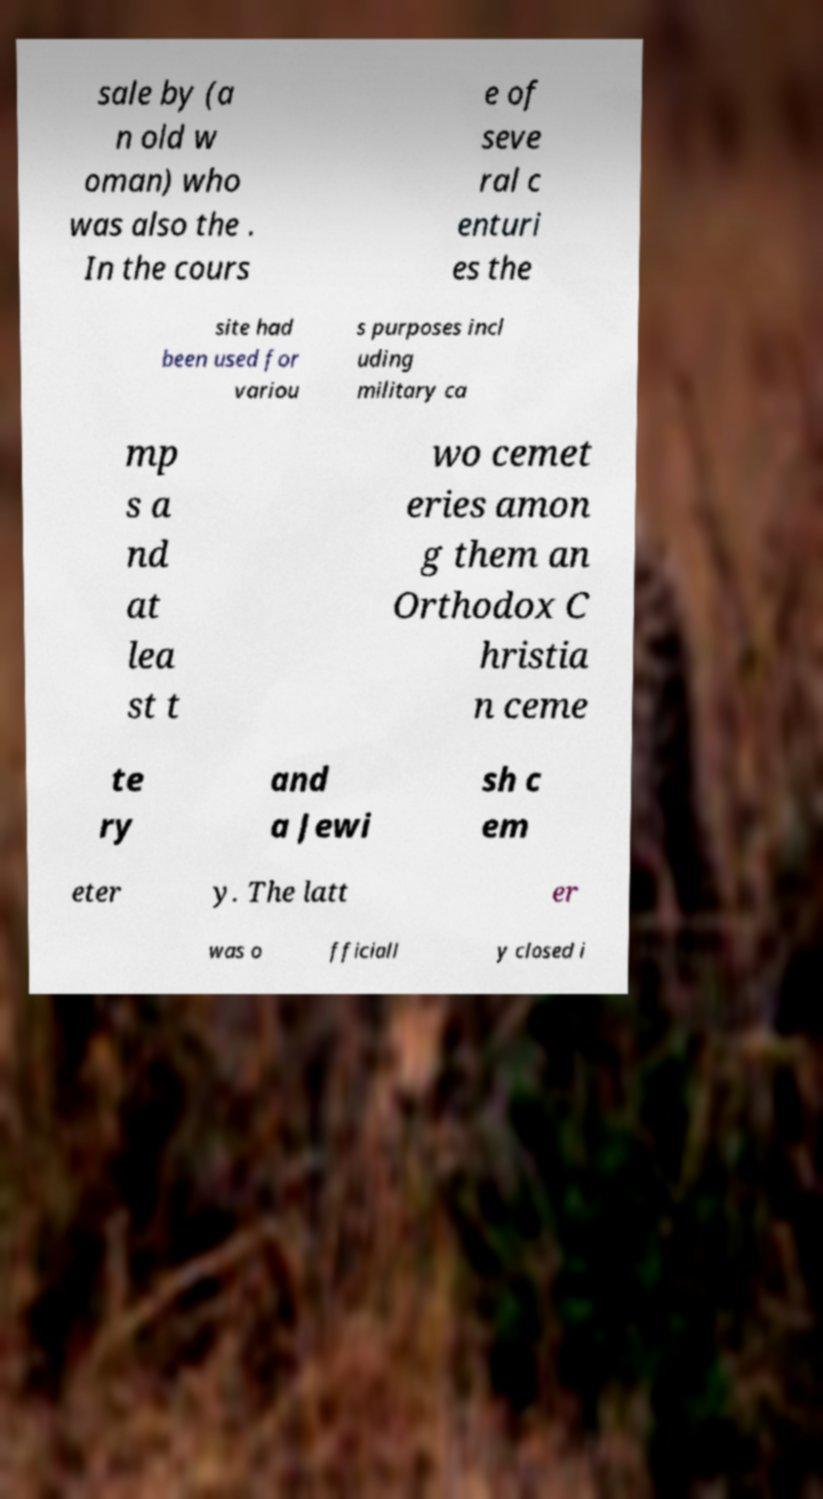There's text embedded in this image that I need extracted. Can you transcribe it verbatim? sale by (a n old w oman) who was also the . In the cours e of seve ral c enturi es the site had been used for variou s purposes incl uding military ca mp s a nd at lea st t wo cemet eries amon g them an Orthodox C hristia n ceme te ry and a Jewi sh c em eter y. The latt er was o fficiall y closed i 